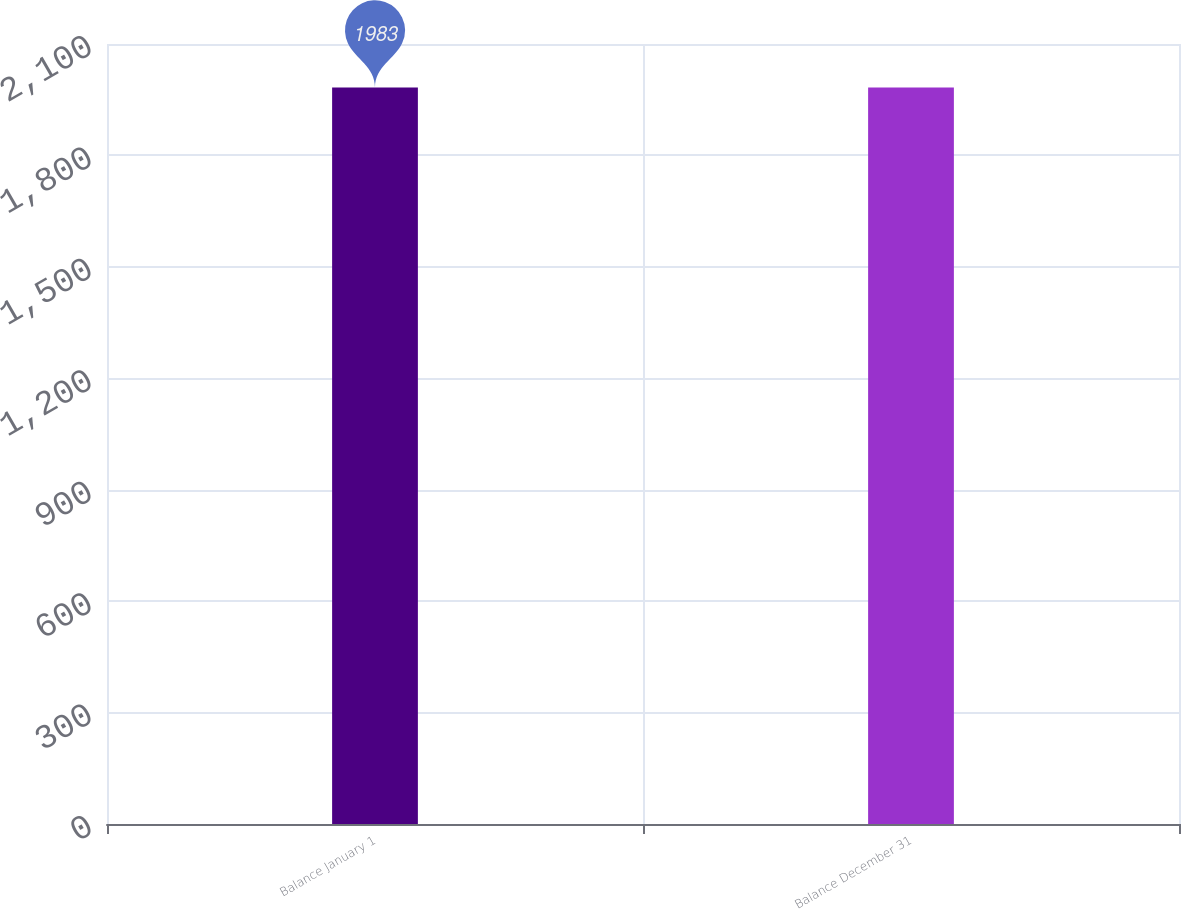Convert chart to OTSL. <chart><loc_0><loc_0><loc_500><loc_500><bar_chart><fcel>Balance January 1<fcel>Balance December 31<nl><fcel>1983<fcel>1983.1<nl></chart> 